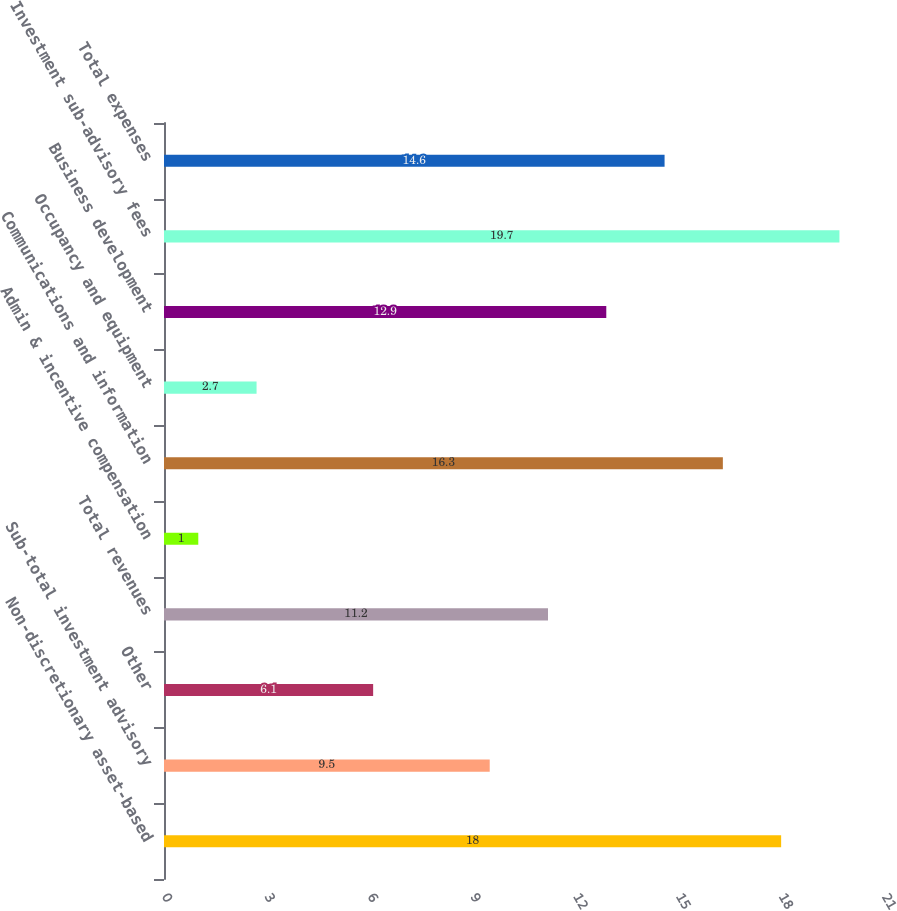Convert chart to OTSL. <chart><loc_0><loc_0><loc_500><loc_500><bar_chart><fcel>Non-discretionary asset-based<fcel>Sub-total investment advisory<fcel>Other<fcel>Total revenues<fcel>Admin & incentive compensation<fcel>Communications and information<fcel>Occupancy and equipment<fcel>Business development<fcel>Investment sub-advisory fees<fcel>Total expenses<nl><fcel>18<fcel>9.5<fcel>6.1<fcel>11.2<fcel>1<fcel>16.3<fcel>2.7<fcel>12.9<fcel>19.7<fcel>14.6<nl></chart> 